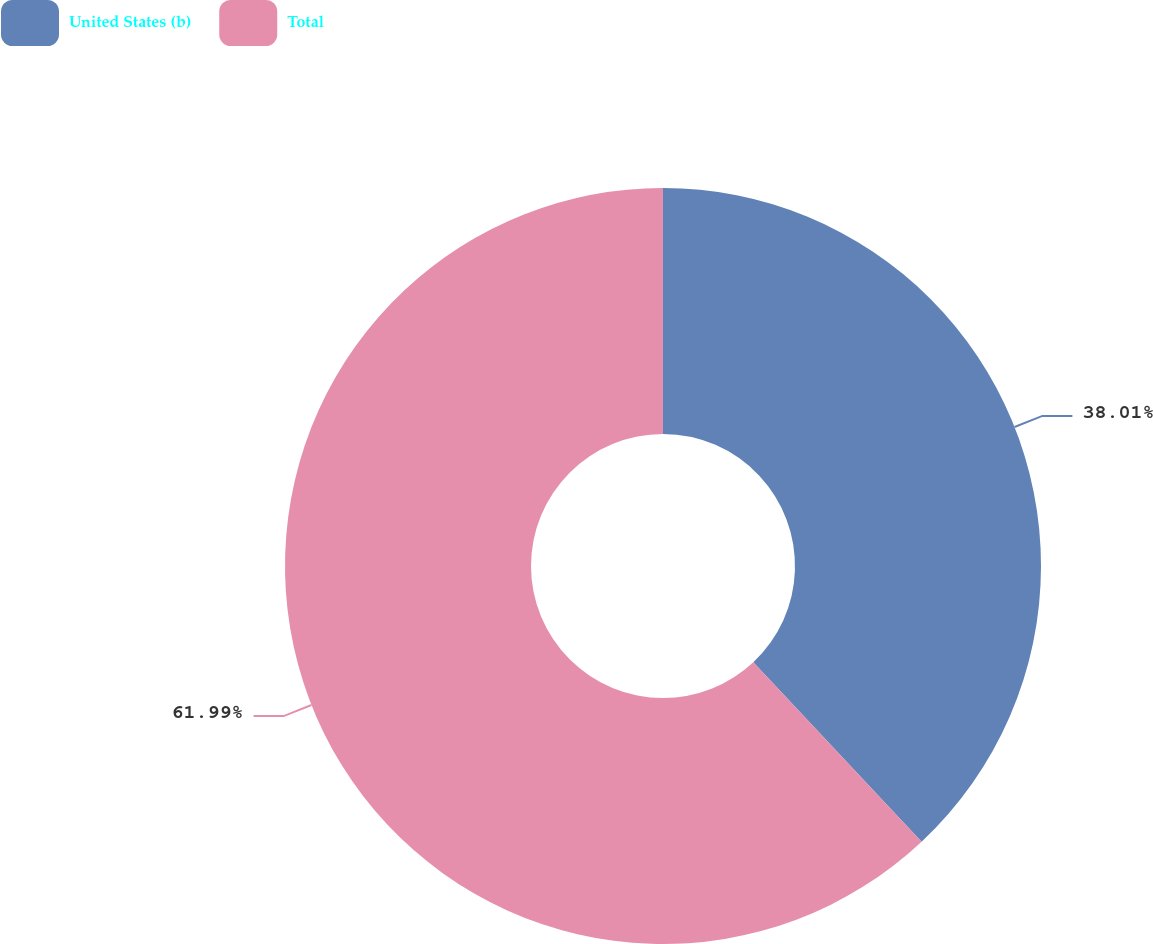Convert chart to OTSL. <chart><loc_0><loc_0><loc_500><loc_500><pie_chart><fcel>United States (b)<fcel>Total<nl><fcel>38.01%<fcel>61.99%<nl></chart> 